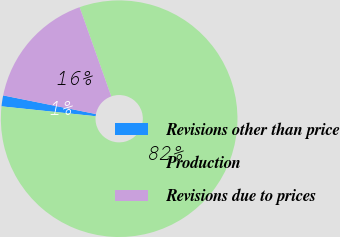Convert chart. <chart><loc_0><loc_0><loc_500><loc_500><pie_chart><fcel>Revisions other than price<fcel>Production<fcel>Revisions due to prices<nl><fcel>1.49%<fcel>82.09%<fcel>16.42%<nl></chart> 